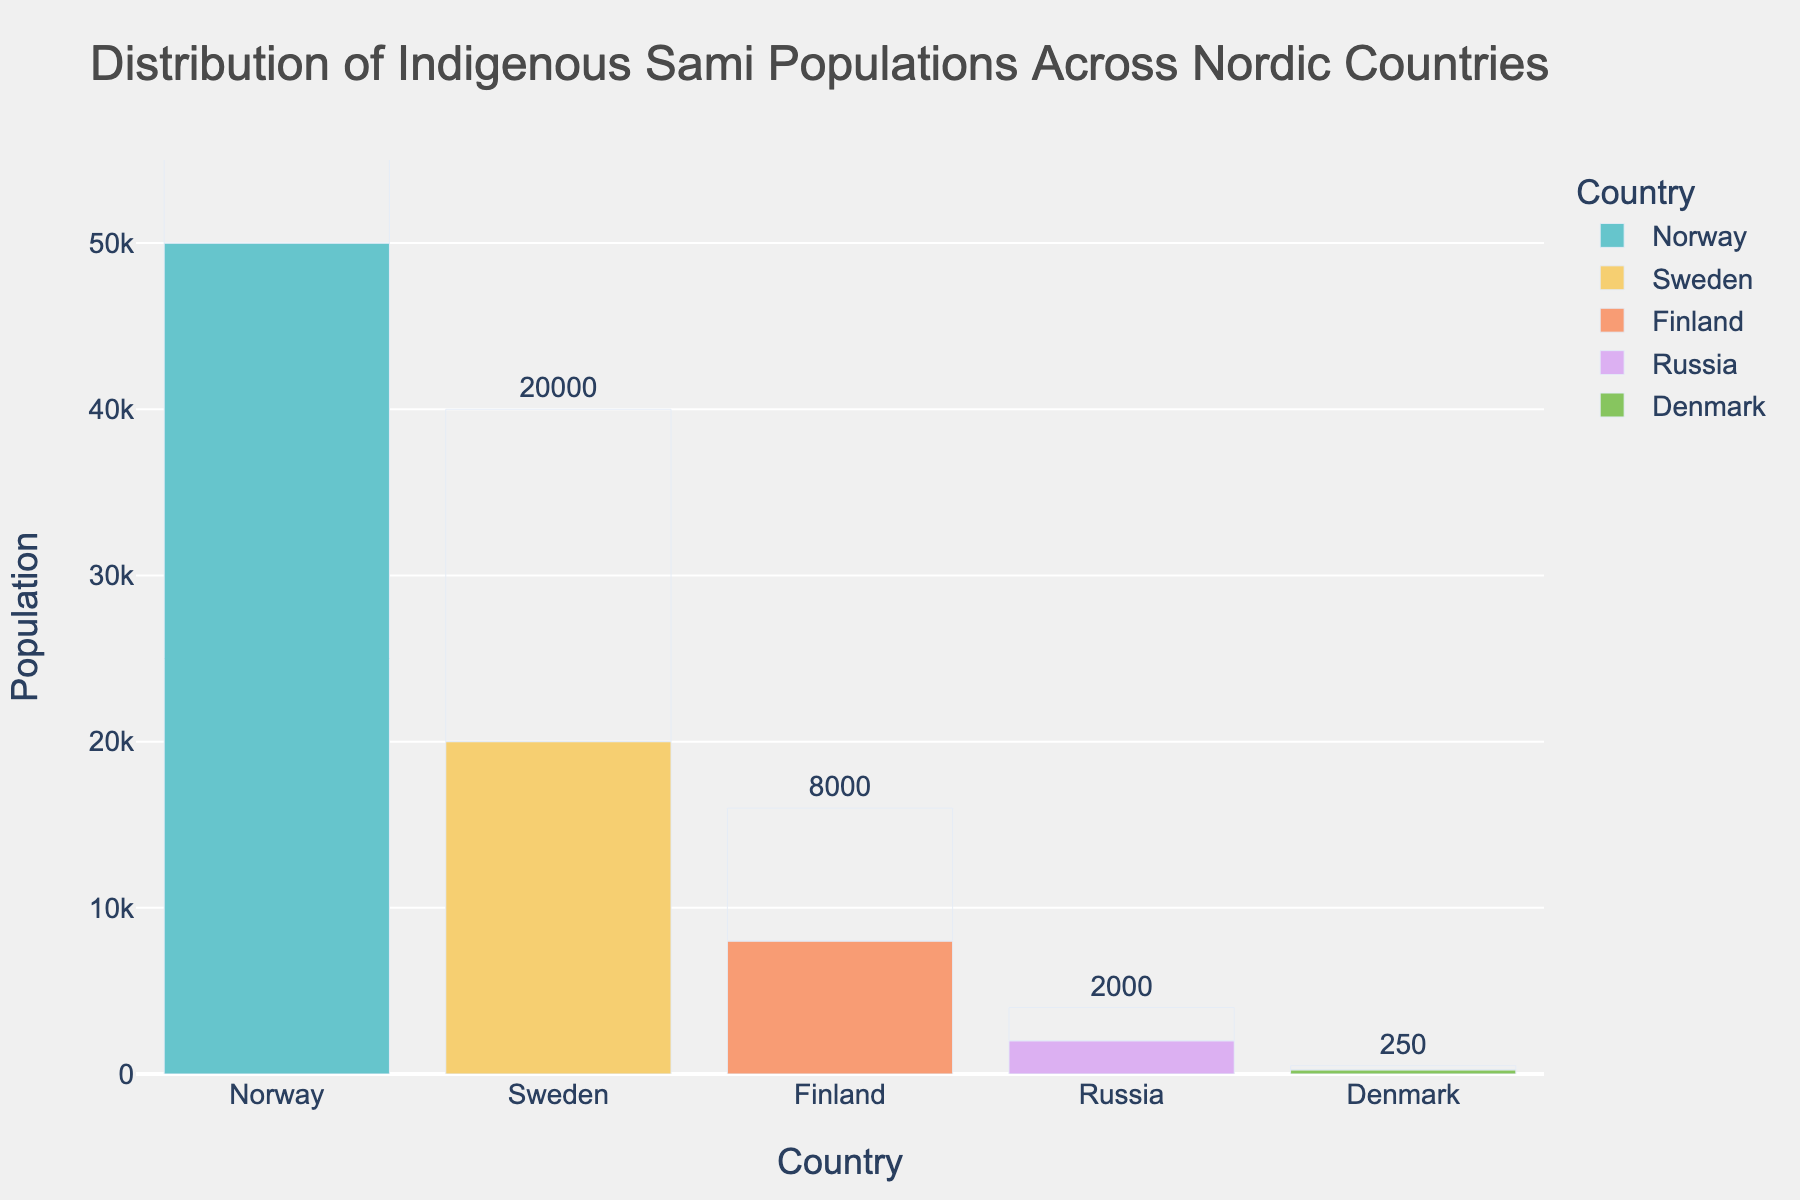Which country has the highest Sami population? The bar representing Norway is the tallest among all the countries, indicating it has the highest Sami population.
Answer: Norway What is the total Sami population across all countries in the chart? Sum the Sami populations: 50000 (Norway) + 20000 (Sweden) + 8000 (Finland) + 2000 (Russia) + 250 (Denmark) = 80250.
Answer: 80250 How does the Sami population in Finland compare to that in Russia? The bar for Finland is significantly taller than the bar for Russia, indicating that Finland has a higher Sami population. Specifically, Finland has 8000 while Russia has 2000.
Answer: Finland has a higher Sami population than Russia What would be the average Sami population if it were equally distributed across the five countries? Calculate the average by dividing the total Sami population by the number of countries: 80250 / 5 = 16050.
Answer: 16050 Which country has the least Sami population, and how much less is it compared to the country with the second least population? Denmark has the least with 250, and Russia has the second least with 2000. The difference is 2000 - 250 = 1750.
Answer: Denmark, 1750 less What is the combined Sami population of Norway and Sweden? Add the Sami populations: 50000 (Norway) + 20000 (Sweden) = 70000.
Answer: 70000 What is the difference in Sami population between the country with the most and the country with the least? Subtract: 50000 (Norway) - 250 (Denmark) = 49750.
Answer: 49750 If Russia's Sami population doubled, would it surpass Finland's Sami population? Doubling Russia's Sami population: 2 * 2000 = 4000. Since 4000 is still less than Finland's 8000, it would not surpass.
Answer: No What proportion of the total Sami population does Sweden account for? Calculate the proportion: 20000 / 80250 ≈ 0.2492, which is about 24.92%.
Answer: About 24.92% Compare the Sami population in Sweden and Denmark. How many times greater is Sweden's Sami population? Divide Sweden's Sami population by Denmark's: 20000 / 250 = 80.
Answer: 80 times greater 